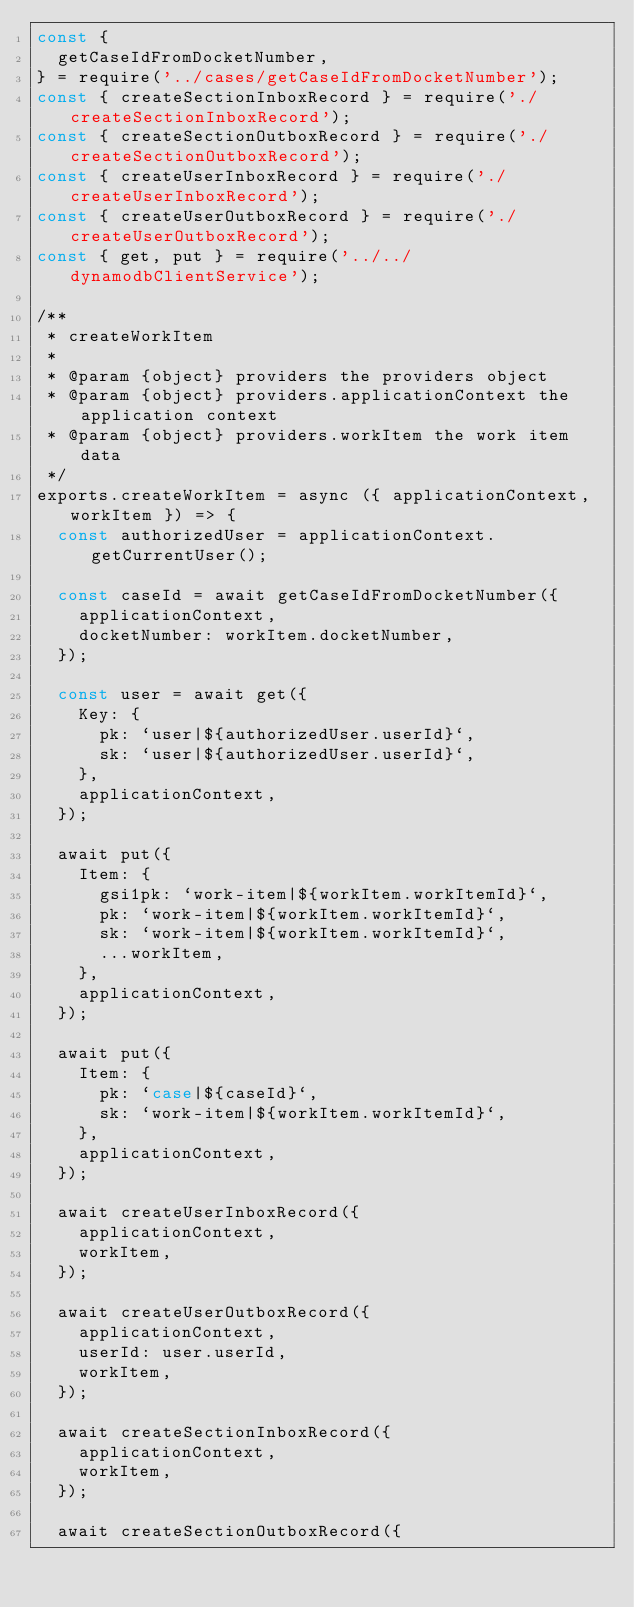Convert code to text. <code><loc_0><loc_0><loc_500><loc_500><_JavaScript_>const {
  getCaseIdFromDocketNumber,
} = require('../cases/getCaseIdFromDocketNumber');
const { createSectionInboxRecord } = require('./createSectionInboxRecord');
const { createSectionOutboxRecord } = require('./createSectionOutboxRecord');
const { createUserInboxRecord } = require('./createUserInboxRecord');
const { createUserOutboxRecord } = require('./createUserOutboxRecord');
const { get, put } = require('../../dynamodbClientService');

/**
 * createWorkItem
 *
 * @param {object} providers the providers object
 * @param {object} providers.applicationContext the application context
 * @param {object} providers.workItem the work item data
 */
exports.createWorkItem = async ({ applicationContext, workItem }) => {
  const authorizedUser = applicationContext.getCurrentUser();

  const caseId = await getCaseIdFromDocketNumber({
    applicationContext,
    docketNumber: workItem.docketNumber,
  });

  const user = await get({
    Key: {
      pk: `user|${authorizedUser.userId}`,
      sk: `user|${authorizedUser.userId}`,
    },
    applicationContext,
  });

  await put({
    Item: {
      gsi1pk: `work-item|${workItem.workItemId}`,
      pk: `work-item|${workItem.workItemId}`,
      sk: `work-item|${workItem.workItemId}`,
      ...workItem,
    },
    applicationContext,
  });

  await put({
    Item: {
      pk: `case|${caseId}`,
      sk: `work-item|${workItem.workItemId}`,
    },
    applicationContext,
  });

  await createUserInboxRecord({
    applicationContext,
    workItem,
  });

  await createUserOutboxRecord({
    applicationContext,
    userId: user.userId,
    workItem,
  });

  await createSectionInboxRecord({
    applicationContext,
    workItem,
  });

  await createSectionOutboxRecord({</code> 